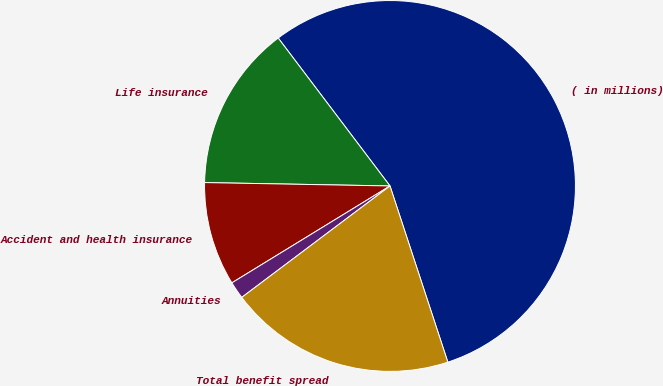Convert chart. <chart><loc_0><loc_0><loc_500><loc_500><pie_chart><fcel>( in millions)<fcel>Life insurance<fcel>Accident and health insurance<fcel>Annuities<fcel>Total benefit spread<nl><fcel>55.25%<fcel>14.41%<fcel>9.04%<fcel>1.51%<fcel>19.79%<nl></chart> 